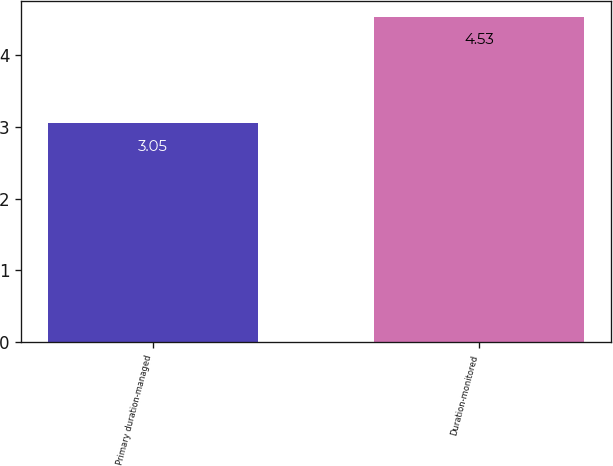Convert chart to OTSL. <chart><loc_0><loc_0><loc_500><loc_500><bar_chart><fcel>Primary duration-managed<fcel>Duration-monitored<nl><fcel>3.05<fcel>4.53<nl></chart> 